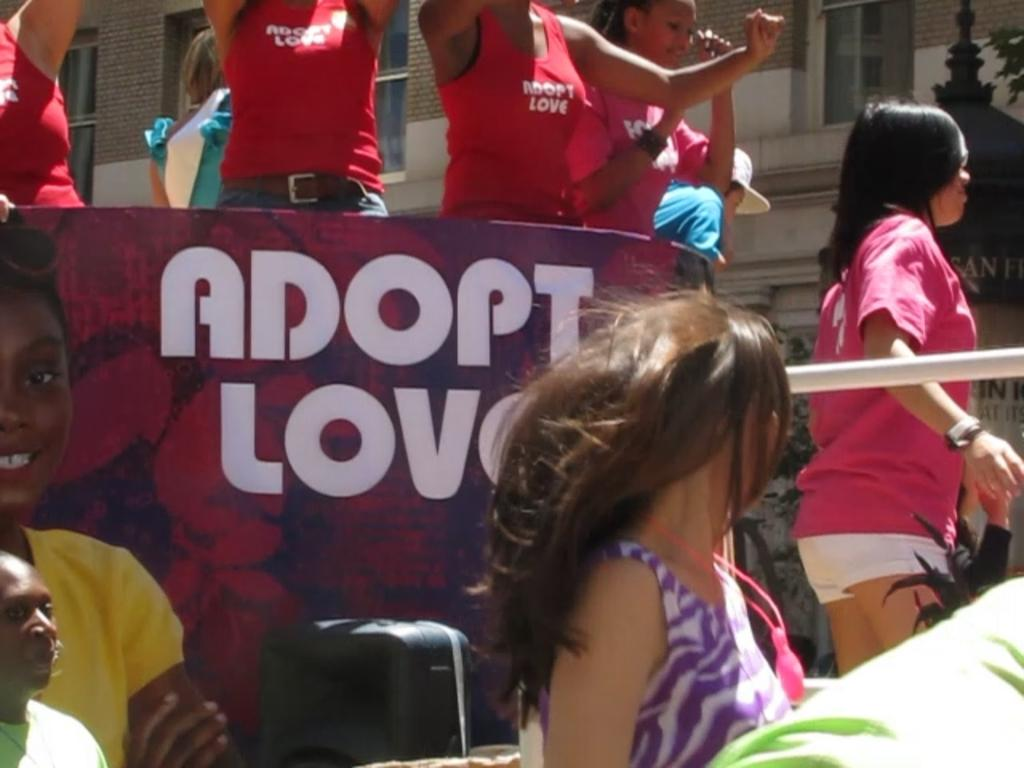Provide a one-sentence caption for the provided image. A group of children are riding a parade float that says Adopt Love. 